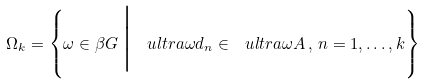Convert formula to latex. <formula><loc_0><loc_0><loc_500><loc_500>\Omega _ { k } = \left \{ \omega \in \beta G \, \Big | \, \ u l t r a { \omega } d _ { n } \in \ u l t r a { \omega } A \, , \, n = 1 , \dots , k \right \}</formula> 